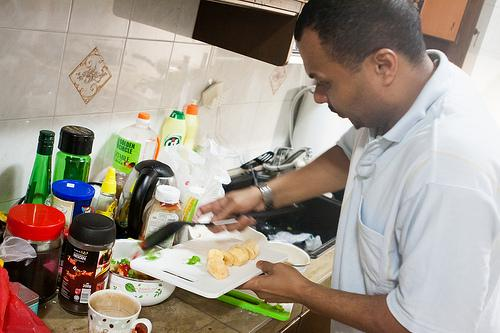Mention three items that are either black or brown in the image. Three such items are the ladle which is black, the table having a wooden and brown look, and a browngold design on the wall. What are some of the objects found on the counter in the image? Some objects on the counter include an empty white spotted coffee mug, a jar with a dark lid, a green bottle, a ketchup bottle, and a coffee pot. Analyze the image to find the state of the coffee mug and its color. The coffee mug is empty, dirty, and white with spots. Count the total number of bottles in the image and give a brief description of them. There are at least five bottles in the image, including ketchup, salad dressing, a green one on the back of the counter, one with dark lid, and another on the counter. Examine the details about the man's appearance, including his head and right hand. The man has dark black hair, a left ear on his head, and is holding a black spatula in his right hand. What is the primary activity happening in the image, and what is the setting? A man is cooking and preparing food in a kitchen setting. Identify the two main colors related to the shirt and the wristwatch the man is wearing. The man's shirt is white and the wristwatch is silver. Describe the features and content of the plate in the image. The plate is rectangular, white in color, and contains sliced banana along with various fruits, greens, and veggies. Summarize what the man in the image is doing and what he is wearing. The man in the image is cooking in a kitchen, putting food into a bowl, and wearing a light blue t-shirt with a white pocket on the shirt. Which type of dressing is mentioned in the image, and which beverage is seen in a cup? Salad dressing is mentioned, and a brown liquid (possibly coffee) is seen in the cup. 